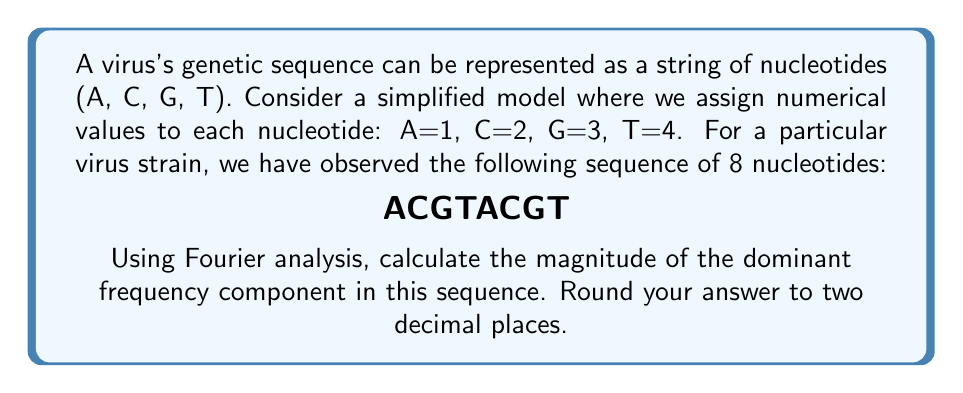Teach me how to tackle this problem. To solve this problem, we'll follow these steps:

1) First, convert the genetic sequence to numerical values:
   A C G T A C G T
   1 2 3 4 1 2 3 4

2) Now, we'll apply the Discrete Fourier Transform (DFT) to this sequence. The DFT is given by:

   $$X_k = \sum_{n=0}^{N-1} x_n e^{-i2\pi kn/N}$$

   where $X_k$ is the $k$-th Fourier coefficient, $x_n$ is the $n$-th value in our sequence, $N$ is the total number of points (8 in this case), and $k$ ranges from 0 to $N-1$.

3) Let's calculate $X_k$ for $k = 0, 1, 2, 3, 4, 5, 6, 7$:

   $X_0 = 1 + 2 + 3 + 4 + 1 + 2 + 3 + 4 = 20$

   $X_1 = 1 - i2 - 3 + 4i + 1 - i2 - 3 + 4i = -4 + 6i$

   $X_2 = 1 - 2 + 3 - 4 + 1 - 2 + 3 - 4 = -4$

   $X_3 = 1 + i2 - 3 - 4i + 1 + i2 - 3 - 4i = -4 - 6i$

   $X_4 = 1 + 2 + 3 + 4 - 1 - 2 - 3 - 4 = 0$

   $X_5 = 1 - i2 - 3 + 4i - 1 + i2 + 3 - 4i = 0$

   $X_6 = 1 - 2 + 3 - 4 - 1 + 2 - 3 + 4 = 0$

   $X_7 = 1 + i2 - 3 - 4i - 1 - i2 + 3 + 4i = 0$

4) The magnitude of each frequency component is given by $|X_k| = \sqrt{\text{Re}(X_k)^2 + \text{Im}(X_k)^2}$:

   $|X_0| = 20$
   $|X_1| = |X_3| = \sqrt{(-4)^2 + 6^2} = \sqrt{52} \approx 7.21$
   $|X_2| = 4$
   $|X_4| = |X_5| = |X_6| = |X_7| = 0$

5) The dominant frequency component is the one with the largest magnitude, which is $|X_0| = 20$.
Answer: 20.00 